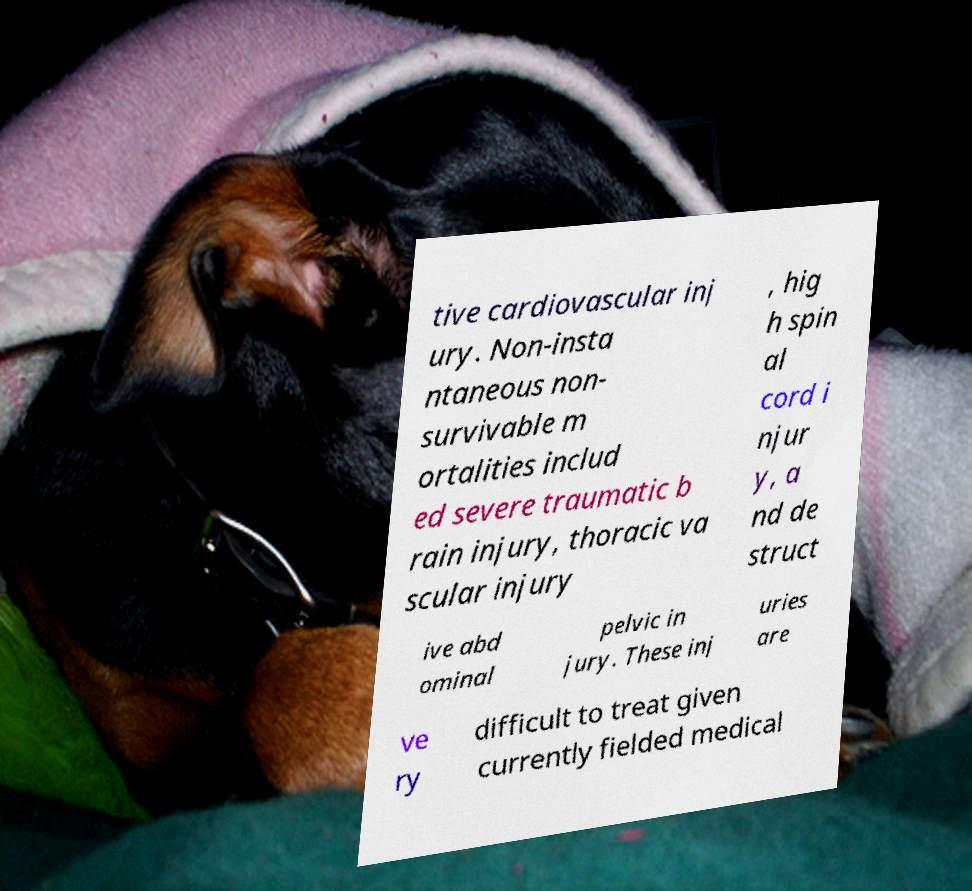I need the written content from this picture converted into text. Can you do that? tive cardiovascular inj ury. Non-insta ntaneous non- survivable m ortalities includ ed severe traumatic b rain injury, thoracic va scular injury , hig h spin al cord i njur y, a nd de struct ive abd ominal pelvic in jury. These inj uries are ve ry difficult to treat given currently fielded medical 